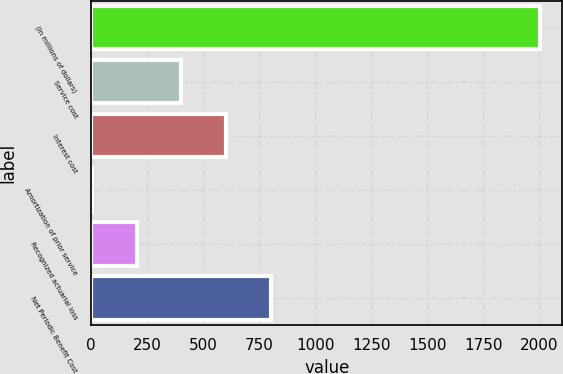Convert chart. <chart><loc_0><loc_0><loc_500><loc_500><bar_chart><fcel>(In millions of dollars)<fcel>Service cost<fcel>Interest cost<fcel>Amortization of prior service<fcel>Recognized actuarial loss<fcel>Net Periodic Benefit Cost<nl><fcel>2004<fcel>402.4<fcel>602.6<fcel>2<fcel>202.2<fcel>802.8<nl></chart> 